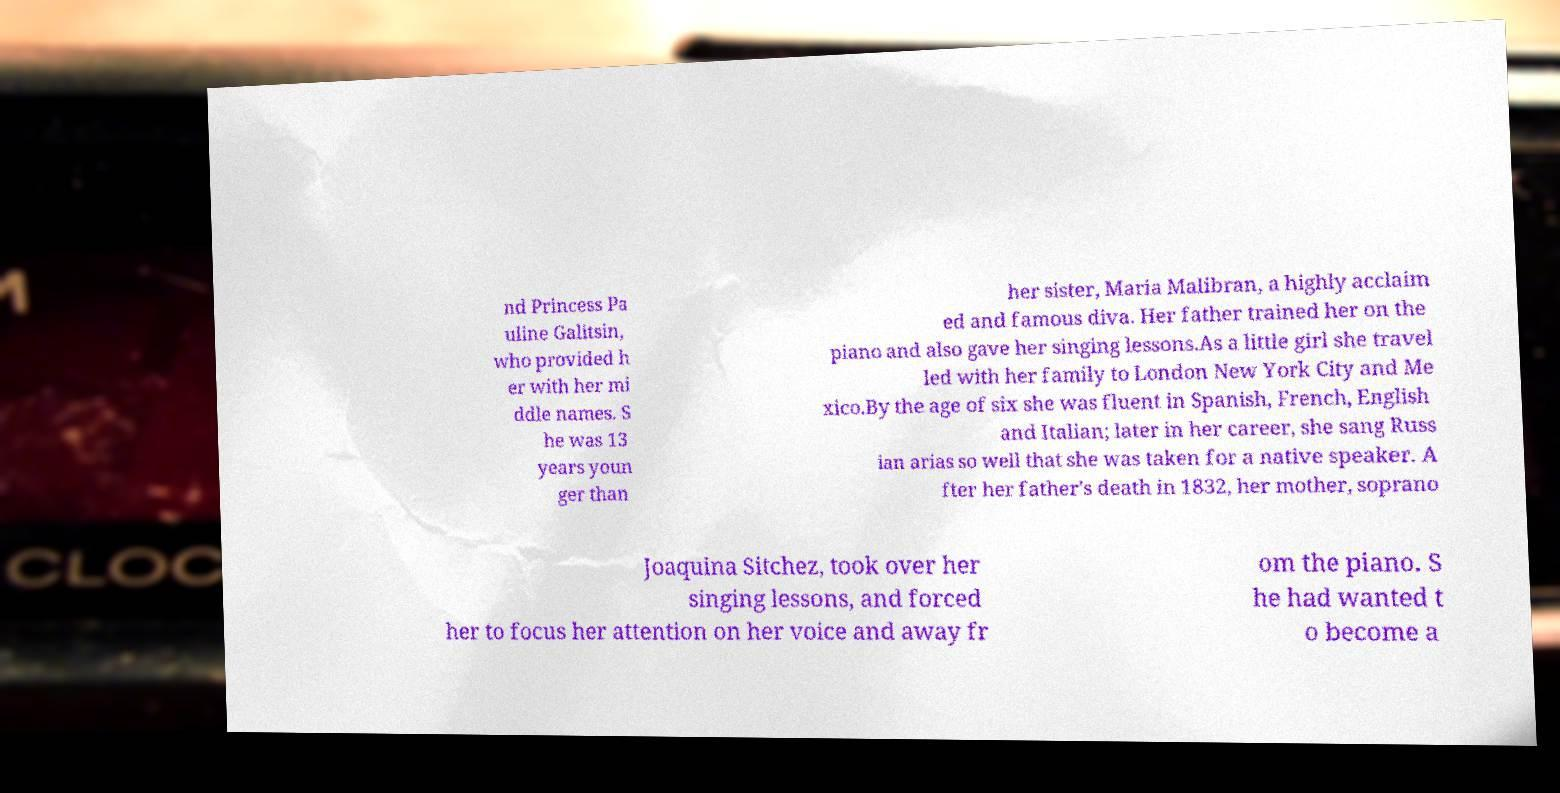There's text embedded in this image that I need extracted. Can you transcribe it verbatim? nd Princess Pa uline Galitsin, who provided h er with her mi ddle names. S he was 13 years youn ger than her sister, Maria Malibran, a highly acclaim ed and famous diva. Her father trained her on the piano and also gave her singing lessons.As a little girl she travel led with her family to London New York City and Me xico.By the age of six she was fluent in Spanish, French, English and Italian; later in her career, she sang Russ ian arias so well that she was taken for a native speaker. A fter her father's death in 1832, her mother, soprano Joaquina Sitchez, took over her singing lessons, and forced her to focus her attention on her voice and away fr om the piano. S he had wanted t o become a 